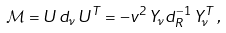Convert formula to latex. <formula><loc_0><loc_0><loc_500><loc_500>\mathcal { M } = U \, d _ { \nu } \, U ^ { T } = - v ^ { 2 } \, Y _ { \nu } d _ { R } ^ { - 1 } \, Y _ { \nu } ^ { T } \, ,</formula> 